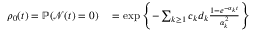Convert formula to latex. <formula><loc_0><loc_0><loc_500><loc_500>\begin{array} { r l } { \rho _ { 0 } ( t ) = \mathbb { P } ( \mathcal { N } ( t ) = 0 ) } & = \exp \left \{ - \sum _ { k \geq 1 } c _ { k } d _ { k } \frac { 1 - e ^ { - \alpha _ { k } t } } { \alpha _ { k } ^ { 2 } } \right \} } \end{array}</formula> 